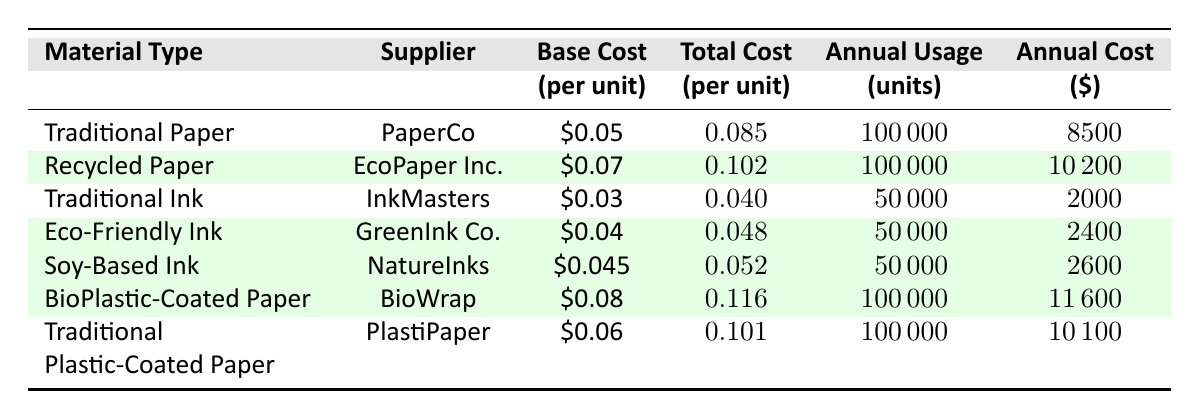What is the total annual cost of traditional paper? The total annual cost of traditional paper is explicitly listed in the table under the "Total Annual Cost" column for Traditional Paper, which states 8500.
Answer: 8500 What is the base cost per unit of recycled paper? The base cost per unit of recycled paper is displayed in the table under the "Base Cost" column for Recycled Paper, showing it as 0.07.
Answer: 0.07 Which material type incurs the highest annual cost? To find the highest annual cost, we can compare the "Total Annual Cost" values for each material. The values are 8500 for Traditional Paper, 10200 for Recycled Paper, 2000 for Traditional Ink, 2400 for Eco-Friendly Ink, 2600 for Soy-Based Ink, 11600 for BioPlastic-Coated Paper, and 10100 for Traditional Plastic-Coated Paper. The highest value is 11600 for BioPlastic-Coated Paper.
Answer: BioPlastic-Coated Paper Is the total cost per unit of eco-friendly ink lower than that of traditional ink? The total cost per unit for Eco-Friendly Ink is 0.048, while for Traditional Ink it is 0.04, indicating that Eco-Friendly Ink is actually more expensive than Traditional Ink when considering total cost per unit, hence the answer is no.
Answer: No Calculate the difference in annual cost between recycled paper and traditional paper. The total annual cost for Recycled Paper is 10200 and for Traditional Paper is 8500. We subtract 8500 from 10200, resulting in 10200 - 8500 = 700.
Answer: 700 What percentage more expensive is the bio-plastic coated paper compared to the traditional paper on a per unit basis? The total cost per unit of BioPlastic-Coated Paper is 0.116 and Traditional Paper is 0.085. The difference is 0.116 - 0.085 = 0.031. To find the percentage increase, we divide this difference by the base cost of Traditional Paper (0.085) and multiply by 100. (0.031 / 0.085) * 100 = 36.47%.
Answer: 36.47% Does eco-friendly ink have a higher base cost per unit than traditional ink? The base cost for Eco-Friendly Ink is 0.04 and for Traditional Ink is 0.03. Since 0.04 is greater than 0.03, the statement is true.
Answer: Yes What is the average total annual cost of all types of inks listed in the table? The total annual costs for the inks are 2000 for Traditional Ink, 2400 for Eco-Friendly Ink, and 2600 for Soy-Based Ink. The sum is 2000 + 2400 + 2600 = 7000. There are 3 types of inks, so we divide 7000 by 3, which gives us 2333.33.
Answer: 2333.33 Which supplier has the lowest total annual cost for their material? Examining the "Total Annual Cost" values, we find 2000 for Traditional Ink (InkMasters), 2400 for Eco-Friendly Ink (GreenInk Co.), and 2600 for Soy-Based Ink (NatureInks) are below 8500 (Traditional Paper) and 10200 (Recycled Paper). The lowest is 2000 for InkMasters.
Answer: InkMasters 